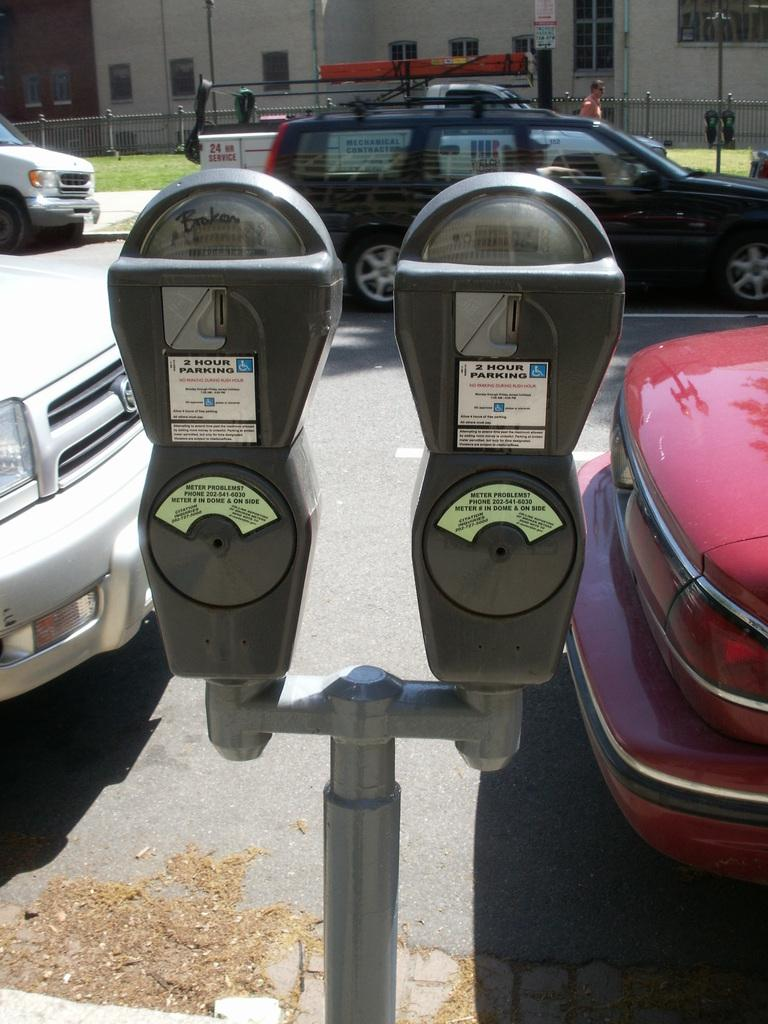<image>
Write a terse but informative summary of the picture. Two different Parking meters with a handicap sign on the right side of them. 